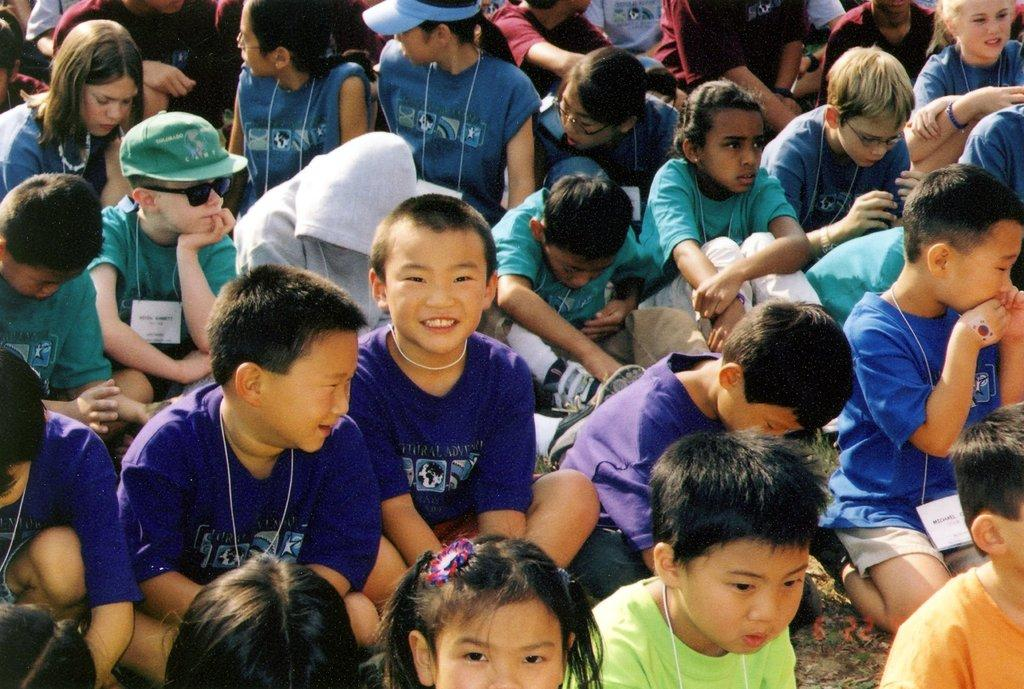What is the main subject of the image? The main subject of the image is a group of people. What are the people in the image doing? The people are sitting. Are there any children in the group? Yes, there are kids in the group. What can be observed about the kids in the image? The kids are wearing tags. What type of kettle can be seen in the image? There is no kettle present in the image. Are there any bears interacting with the kids in the image? There are no bears present in the image. 